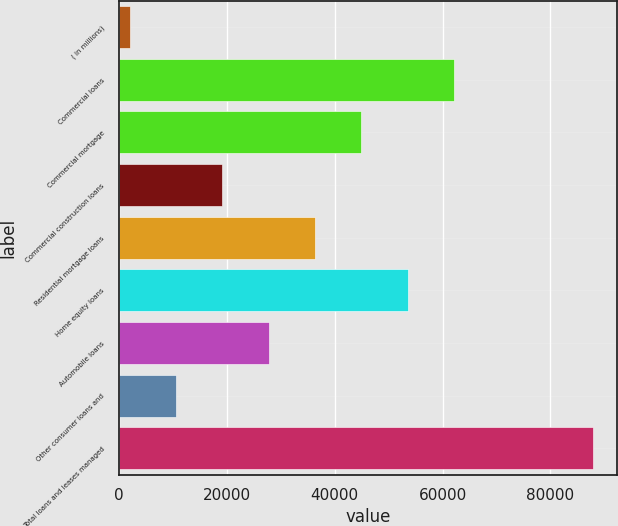<chart> <loc_0><loc_0><loc_500><loc_500><bar_chart><fcel>( in millions)<fcel>Commercial loans<fcel>Commercial mortgage<fcel>Commercial construction loans<fcel>Residential mortgage loans<fcel>Home equity loans<fcel>Automobile loans<fcel>Other consumer loans and<fcel>Total loans and leases managed<nl><fcel>2007<fcel>62107.6<fcel>44936<fcel>19178.6<fcel>36350.2<fcel>53521.8<fcel>27764.4<fcel>10592.8<fcel>87865<nl></chart> 